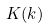<formula> <loc_0><loc_0><loc_500><loc_500>K ( k )</formula> 